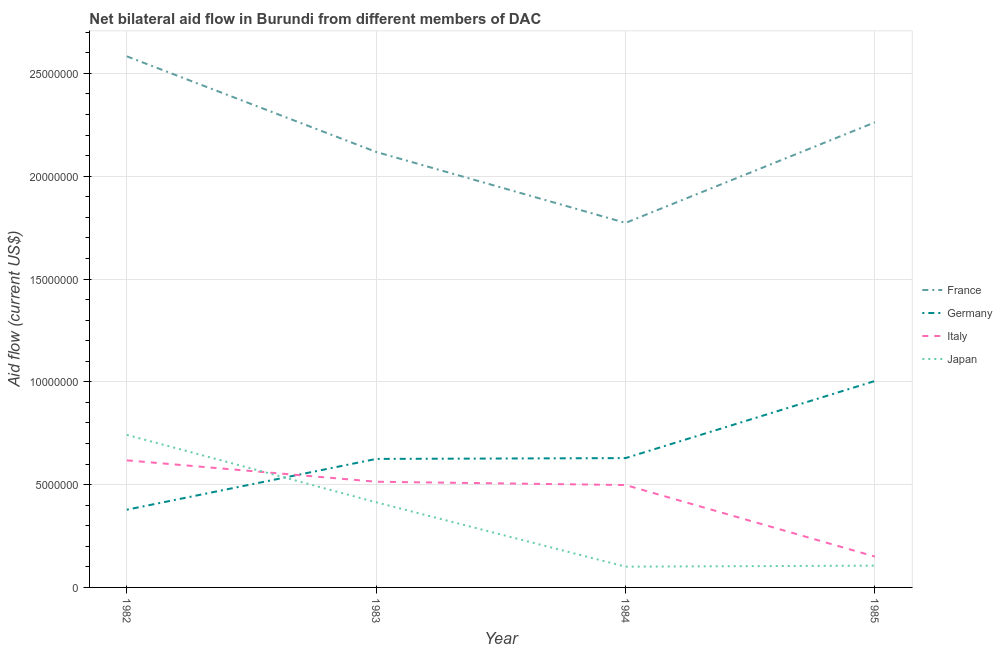How many different coloured lines are there?
Provide a succinct answer. 4. Does the line corresponding to amount of aid given by france intersect with the line corresponding to amount of aid given by germany?
Your answer should be very brief. No. Is the number of lines equal to the number of legend labels?
Make the answer very short. Yes. What is the amount of aid given by italy in 1985?
Ensure brevity in your answer.  1.50e+06. Across all years, what is the maximum amount of aid given by france?
Offer a terse response. 2.58e+07. Across all years, what is the minimum amount of aid given by japan?
Your answer should be very brief. 1.01e+06. In which year was the amount of aid given by italy maximum?
Keep it short and to the point. 1982. In which year was the amount of aid given by italy minimum?
Offer a terse response. 1985. What is the total amount of aid given by france in the graph?
Provide a succinct answer. 8.74e+07. What is the difference between the amount of aid given by france in 1982 and that in 1985?
Offer a very short reply. 3.21e+06. What is the difference between the amount of aid given by germany in 1982 and the amount of aid given by italy in 1983?
Make the answer very short. -1.36e+06. What is the average amount of aid given by italy per year?
Keep it short and to the point. 4.45e+06. In the year 1984, what is the difference between the amount of aid given by germany and amount of aid given by france?
Give a very brief answer. -1.14e+07. In how many years, is the amount of aid given by germany greater than 13000000 US$?
Ensure brevity in your answer.  0. What is the ratio of the amount of aid given by germany in 1983 to that in 1985?
Make the answer very short. 0.62. Is the amount of aid given by italy in 1982 less than that in 1983?
Provide a short and direct response. No. Is the difference between the amount of aid given by france in 1983 and 1984 greater than the difference between the amount of aid given by germany in 1983 and 1984?
Make the answer very short. Yes. What is the difference between the highest and the second highest amount of aid given by japan?
Offer a very short reply. 3.28e+06. What is the difference between the highest and the lowest amount of aid given by france?
Make the answer very short. 8.10e+06. Is it the case that in every year, the sum of the amount of aid given by italy and amount of aid given by japan is greater than the sum of amount of aid given by germany and amount of aid given by france?
Your answer should be compact. No. Is it the case that in every year, the sum of the amount of aid given by france and amount of aid given by germany is greater than the amount of aid given by italy?
Your answer should be compact. Yes. Does the amount of aid given by italy monotonically increase over the years?
Your response must be concise. No. Is the amount of aid given by france strictly greater than the amount of aid given by japan over the years?
Your response must be concise. Yes. Is the amount of aid given by japan strictly less than the amount of aid given by italy over the years?
Provide a succinct answer. No. How many lines are there?
Your answer should be compact. 4. How many years are there in the graph?
Your response must be concise. 4. What is the difference between two consecutive major ticks on the Y-axis?
Ensure brevity in your answer.  5.00e+06. Does the graph contain any zero values?
Offer a very short reply. No. How many legend labels are there?
Offer a terse response. 4. How are the legend labels stacked?
Keep it short and to the point. Vertical. What is the title of the graph?
Keep it short and to the point. Net bilateral aid flow in Burundi from different members of DAC. What is the Aid flow (current US$) in France in 1982?
Offer a terse response. 2.58e+07. What is the Aid flow (current US$) of Germany in 1982?
Your answer should be very brief. 3.78e+06. What is the Aid flow (current US$) in Italy in 1982?
Offer a terse response. 6.18e+06. What is the Aid flow (current US$) of Japan in 1982?
Offer a very short reply. 7.42e+06. What is the Aid flow (current US$) of France in 1983?
Your answer should be very brief. 2.12e+07. What is the Aid flow (current US$) in Germany in 1983?
Keep it short and to the point. 6.25e+06. What is the Aid flow (current US$) in Italy in 1983?
Ensure brevity in your answer.  5.14e+06. What is the Aid flow (current US$) in Japan in 1983?
Offer a terse response. 4.14e+06. What is the Aid flow (current US$) in France in 1984?
Provide a succinct answer. 1.77e+07. What is the Aid flow (current US$) of Germany in 1984?
Your answer should be very brief. 6.29e+06. What is the Aid flow (current US$) of Italy in 1984?
Offer a terse response. 4.98e+06. What is the Aid flow (current US$) of Japan in 1984?
Offer a very short reply. 1.01e+06. What is the Aid flow (current US$) of France in 1985?
Provide a short and direct response. 2.26e+07. What is the Aid flow (current US$) of Germany in 1985?
Make the answer very short. 1.00e+07. What is the Aid flow (current US$) in Italy in 1985?
Provide a succinct answer. 1.50e+06. What is the Aid flow (current US$) of Japan in 1985?
Ensure brevity in your answer.  1.06e+06. Across all years, what is the maximum Aid flow (current US$) in France?
Offer a terse response. 2.58e+07. Across all years, what is the maximum Aid flow (current US$) of Germany?
Ensure brevity in your answer.  1.00e+07. Across all years, what is the maximum Aid flow (current US$) of Italy?
Make the answer very short. 6.18e+06. Across all years, what is the maximum Aid flow (current US$) in Japan?
Offer a very short reply. 7.42e+06. Across all years, what is the minimum Aid flow (current US$) in France?
Your answer should be compact. 1.77e+07. Across all years, what is the minimum Aid flow (current US$) of Germany?
Your response must be concise. 3.78e+06. Across all years, what is the minimum Aid flow (current US$) of Italy?
Keep it short and to the point. 1.50e+06. Across all years, what is the minimum Aid flow (current US$) in Japan?
Provide a short and direct response. 1.01e+06. What is the total Aid flow (current US$) of France in the graph?
Your answer should be very brief. 8.74e+07. What is the total Aid flow (current US$) in Germany in the graph?
Keep it short and to the point. 2.64e+07. What is the total Aid flow (current US$) in Italy in the graph?
Make the answer very short. 1.78e+07. What is the total Aid flow (current US$) in Japan in the graph?
Your answer should be compact. 1.36e+07. What is the difference between the Aid flow (current US$) in France in 1982 and that in 1983?
Your answer should be very brief. 4.65e+06. What is the difference between the Aid flow (current US$) in Germany in 1982 and that in 1983?
Provide a succinct answer. -2.47e+06. What is the difference between the Aid flow (current US$) in Italy in 1982 and that in 1983?
Ensure brevity in your answer.  1.04e+06. What is the difference between the Aid flow (current US$) in Japan in 1982 and that in 1983?
Your answer should be very brief. 3.28e+06. What is the difference between the Aid flow (current US$) in France in 1982 and that in 1984?
Make the answer very short. 8.10e+06. What is the difference between the Aid flow (current US$) of Germany in 1982 and that in 1984?
Your answer should be very brief. -2.51e+06. What is the difference between the Aid flow (current US$) in Italy in 1982 and that in 1984?
Keep it short and to the point. 1.20e+06. What is the difference between the Aid flow (current US$) in Japan in 1982 and that in 1984?
Offer a very short reply. 6.41e+06. What is the difference between the Aid flow (current US$) of France in 1982 and that in 1985?
Provide a succinct answer. 3.21e+06. What is the difference between the Aid flow (current US$) in Germany in 1982 and that in 1985?
Offer a terse response. -6.26e+06. What is the difference between the Aid flow (current US$) in Italy in 1982 and that in 1985?
Your response must be concise. 4.68e+06. What is the difference between the Aid flow (current US$) in Japan in 1982 and that in 1985?
Provide a succinct answer. 6.36e+06. What is the difference between the Aid flow (current US$) in France in 1983 and that in 1984?
Give a very brief answer. 3.45e+06. What is the difference between the Aid flow (current US$) in Italy in 1983 and that in 1984?
Your response must be concise. 1.60e+05. What is the difference between the Aid flow (current US$) in Japan in 1983 and that in 1984?
Your response must be concise. 3.13e+06. What is the difference between the Aid flow (current US$) of France in 1983 and that in 1985?
Offer a very short reply. -1.44e+06. What is the difference between the Aid flow (current US$) in Germany in 1983 and that in 1985?
Keep it short and to the point. -3.79e+06. What is the difference between the Aid flow (current US$) in Italy in 1983 and that in 1985?
Offer a terse response. 3.64e+06. What is the difference between the Aid flow (current US$) of Japan in 1983 and that in 1985?
Ensure brevity in your answer.  3.08e+06. What is the difference between the Aid flow (current US$) in France in 1984 and that in 1985?
Offer a terse response. -4.89e+06. What is the difference between the Aid flow (current US$) of Germany in 1984 and that in 1985?
Offer a terse response. -3.75e+06. What is the difference between the Aid flow (current US$) in Italy in 1984 and that in 1985?
Provide a succinct answer. 3.48e+06. What is the difference between the Aid flow (current US$) of Japan in 1984 and that in 1985?
Provide a succinct answer. -5.00e+04. What is the difference between the Aid flow (current US$) in France in 1982 and the Aid flow (current US$) in Germany in 1983?
Make the answer very short. 1.96e+07. What is the difference between the Aid flow (current US$) of France in 1982 and the Aid flow (current US$) of Italy in 1983?
Make the answer very short. 2.07e+07. What is the difference between the Aid flow (current US$) of France in 1982 and the Aid flow (current US$) of Japan in 1983?
Make the answer very short. 2.17e+07. What is the difference between the Aid flow (current US$) in Germany in 1982 and the Aid flow (current US$) in Italy in 1983?
Offer a terse response. -1.36e+06. What is the difference between the Aid flow (current US$) of Germany in 1982 and the Aid flow (current US$) of Japan in 1983?
Provide a short and direct response. -3.60e+05. What is the difference between the Aid flow (current US$) in Italy in 1982 and the Aid flow (current US$) in Japan in 1983?
Your answer should be very brief. 2.04e+06. What is the difference between the Aid flow (current US$) in France in 1982 and the Aid flow (current US$) in Germany in 1984?
Your response must be concise. 1.95e+07. What is the difference between the Aid flow (current US$) in France in 1982 and the Aid flow (current US$) in Italy in 1984?
Your answer should be compact. 2.08e+07. What is the difference between the Aid flow (current US$) of France in 1982 and the Aid flow (current US$) of Japan in 1984?
Provide a short and direct response. 2.48e+07. What is the difference between the Aid flow (current US$) in Germany in 1982 and the Aid flow (current US$) in Italy in 1984?
Offer a terse response. -1.20e+06. What is the difference between the Aid flow (current US$) in Germany in 1982 and the Aid flow (current US$) in Japan in 1984?
Ensure brevity in your answer.  2.77e+06. What is the difference between the Aid flow (current US$) in Italy in 1982 and the Aid flow (current US$) in Japan in 1984?
Keep it short and to the point. 5.17e+06. What is the difference between the Aid flow (current US$) of France in 1982 and the Aid flow (current US$) of Germany in 1985?
Provide a succinct answer. 1.58e+07. What is the difference between the Aid flow (current US$) in France in 1982 and the Aid flow (current US$) in Italy in 1985?
Give a very brief answer. 2.43e+07. What is the difference between the Aid flow (current US$) in France in 1982 and the Aid flow (current US$) in Japan in 1985?
Give a very brief answer. 2.48e+07. What is the difference between the Aid flow (current US$) in Germany in 1982 and the Aid flow (current US$) in Italy in 1985?
Your answer should be compact. 2.28e+06. What is the difference between the Aid flow (current US$) in Germany in 1982 and the Aid flow (current US$) in Japan in 1985?
Offer a very short reply. 2.72e+06. What is the difference between the Aid flow (current US$) of Italy in 1982 and the Aid flow (current US$) of Japan in 1985?
Make the answer very short. 5.12e+06. What is the difference between the Aid flow (current US$) of France in 1983 and the Aid flow (current US$) of Germany in 1984?
Offer a very short reply. 1.49e+07. What is the difference between the Aid flow (current US$) of France in 1983 and the Aid flow (current US$) of Italy in 1984?
Provide a short and direct response. 1.62e+07. What is the difference between the Aid flow (current US$) in France in 1983 and the Aid flow (current US$) in Japan in 1984?
Ensure brevity in your answer.  2.02e+07. What is the difference between the Aid flow (current US$) in Germany in 1983 and the Aid flow (current US$) in Italy in 1984?
Your answer should be very brief. 1.27e+06. What is the difference between the Aid flow (current US$) in Germany in 1983 and the Aid flow (current US$) in Japan in 1984?
Provide a succinct answer. 5.24e+06. What is the difference between the Aid flow (current US$) in Italy in 1983 and the Aid flow (current US$) in Japan in 1984?
Provide a succinct answer. 4.13e+06. What is the difference between the Aid flow (current US$) in France in 1983 and the Aid flow (current US$) in Germany in 1985?
Provide a short and direct response. 1.11e+07. What is the difference between the Aid flow (current US$) of France in 1983 and the Aid flow (current US$) of Italy in 1985?
Your answer should be compact. 1.97e+07. What is the difference between the Aid flow (current US$) in France in 1983 and the Aid flow (current US$) in Japan in 1985?
Give a very brief answer. 2.01e+07. What is the difference between the Aid flow (current US$) in Germany in 1983 and the Aid flow (current US$) in Italy in 1985?
Your answer should be compact. 4.75e+06. What is the difference between the Aid flow (current US$) of Germany in 1983 and the Aid flow (current US$) of Japan in 1985?
Give a very brief answer. 5.19e+06. What is the difference between the Aid flow (current US$) of Italy in 1983 and the Aid flow (current US$) of Japan in 1985?
Keep it short and to the point. 4.08e+06. What is the difference between the Aid flow (current US$) in France in 1984 and the Aid flow (current US$) in Germany in 1985?
Provide a succinct answer. 7.69e+06. What is the difference between the Aid flow (current US$) of France in 1984 and the Aid flow (current US$) of Italy in 1985?
Offer a terse response. 1.62e+07. What is the difference between the Aid flow (current US$) of France in 1984 and the Aid flow (current US$) of Japan in 1985?
Offer a very short reply. 1.67e+07. What is the difference between the Aid flow (current US$) in Germany in 1984 and the Aid flow (current US$) in Italy in 1985?
Provide a succinct answer. 4.79e+06. What is the difference between the Aid flow (current US$) of Germany in 1984 and the Aid flow (current US$) of Japan in 1985?
Make the answer very short. 5.23e+06. What is the difference between the Aid flow (current US$) in Italy in 1984 and the Aid flow (current US$) in Japan in 1985?
Ensure brevity in your answer.  3.92e+06. What is the average Aid flow (current US$) in France per year?
Make the answer very short. 2.18e+07. What is the average Aid flow (current US$) of Germany per year?
Make the answer very short. 6.59e+06. What is the average Aid flow (current US$) of Italy per year?
Offer a very short reply. 4.45e+06. What is the average Aid flow (current US$) of Japan per year?
Ensure brevity in your answer.  3.41e+06. In the year 1982, what is the difference between the Aid flow (current US$) of France and Aid flow (current US$) of Germany?
Provide a short and direct response. 2.20e+07. In the year 1982, what is the difference between the Aid flow (current US$) of France and Aid flow (current US$) of Italy?
Your response must be concise. 1.96e+07. In the year 1982, what is the difference between the Aid flow (current US$) of France and Aid flow (current US$) of Japan?
Provide a short and direct response. 1.84e+07. In the year 1982, what is the difference between the Aid flow (current US$) in Germany and Aid flow (current US$) in Italy?
Your answer should be compact. -2.40e+06. In the year 1982, what is the difference between the Aid flow (current US$) of Germany and Aid flow (current US$) of Japan?
Your response must be concise. -3.64e+06. In the year 1982, what is the difference between the Aid flow (current US$) of Italy and Aid flow (current US$) of Japan?
Give a very brief answer. -1.24e+06. In the year 1983, what is the difference between the Aid flow (current US$) of France and Aid flow (current US$) of Germany?
Ensure brevity in your answer.  1.49e+07. In the year 1983, what is the difference between the Aid flow (current US$) of France and Aid flow (current US$) of Italy?
Your response must be concise. 1.60e+07. In the year 1983, what is the difference between the Aid flow (current US$) in France and Aid flow (current US$) in Japan?
Your answer should be compact. 1.70e+07. In the year 1983, what is the difference between the Aid flow (current US$) of Germany and Aid flow (current US$) of Italy?
Your response must be concise. 1.11e+06. In the year 1983, what is the difference between the Aid flow (current US$) of Germany and Aid flow (current US$) of Japan?
Offer a very short reply. 2.11e+06. In the year 1983, what is the difference between the Aid flow (current US$) in Italy and Aid flow (current US$) in Japan?
Your response must be concise. 1.00e+06. In the year 1984, what is the difference between the Aid flow (current US$) of France and Aid flow (current US$) of Germany?
Offer a very short reply. 1.14e+07. In the year 1984, what is the difference between the Aid flow (current US$) of France and Aid flow (current US$) of Italy?
Keep it short and to the point. 1.28e+07. In the year 1984, what is the difference between the Aid flow (current US$) in France and Aid flow (current US$) in Japan?
Give a very brief answer. 1.67e+07. In the year 1984, what is the difference between the Aid flow (current US$) in Germany and Aid flow (current US$) in Italy?
Offer a terse response. 1.31e+06. In the year 1984, what is the difference between the Aid flow (current US$) in Germany and Aid flow (current US$) in Japan?
Offer a very short reply. 5.28e+06. In the year 1984, what is the difference between the Aid flow (current US$) in Italy and Aid flow (current US$) in Japan?
Keep it short and to the point. 3.97e+06. In the year 1985, what is the difference between the Aid flow (current US$) in France and Aid flow (current US$) in Germany?
Offer a very short reply. 1.26e+07. In the year 1985, what is the difference between the Aid flow (current US$) in France and Aid flow (current US$) in Italy?
Offer a terse response. 2.11e+07. In the year 1985, what is the difference between the Aid flow (current US$) of France and Aid flow (current US$) of Japan?
Your response must be concise. 2.16e+07. In the year 1985, what is the difference between the Aid flow (current US$) in Germany and Aid flow (current US$) in Italy?
Offer a terse response. 8.54e+06. In the year 1985, what is the difference between the Aid flow (current US$) of Germany and Aid flow (current US$) of Japan?
Provide a short and direct response. 8.98e+06. In the year 1985, what is the difference between the Aid flow (current US$) in Italy and Aid flow (current US$) in Japan?
Your response must be concise. 4.40e+05. What is the ratio of the Aid flow (current US$) of France in 1982 to that in 1983?
Provide a short and direct response. 1.22. What is the ratio of the Aid flow (current US$) in Germany in 1982 to that in 1983?
Make the answer very short. 0.6. What is the ratio of the Aid flow (current US$) in Italy in 1982 to that in 1983?
Your answer should be compact. 1.2. What is the ratio of the Aid flow (current US$) of Japan in 1982 to that in 1983?
Your answer should be compact. 1.79. What is the ratio of the Aid flow (current US$) in France in 1982 to that in 1984?
Provide a short and direct response. 1.46. What is the ratio of the Aid flow (current US$) of Germany in 1982 to that in 1984?
Your response must be concise. 0.6. What is the ratio of the Aid flow (current US$) of Italy in 1982 to that in 1984?
Ensure brevity in your answer.  1.24. What is the ratio of the Aid flow (current US$) in Japan in 1982 to that in 1984?
Keep it short and to the point. 7.35. What is the ratio of the Aid flow (current US$) in France in 1982 to that in 1985?
Your answer should be compact. 1.14. What is the ratio of the Aid flow (current US$) of Germany in 1982 to that in 1985?
Keep it short and to the point. 0.38. What is the ratio of the Aid flow (current US$) in Italy in 1982 to that in 1985?
Offer a very short reply. 4.12. What is the ratio of the Aid flow (current US$) in France in 1983 to that in 1984?
Your answer should be very brief. 1.19. What is the ratio of the Aid flow (current US$) in Italy in 1983 to that in 1984?
Provide a short and direct response. 1.03. What is the ratio of the Aid flow (current US$) in Japan in 1983 to that in 1984?
Your answer should be compact. 4.1. What is the ratio of the Aid flow (current US$) in France in 1983 to that in 1985?
Provide a short and direct response. 0.94. What is the ratio of the Aid flow (current US$) in Germany in 1983 to that in 1985?
Give a very brief answer. 0.62. What is the ratio of the Aid flow (current US$) of Italy in 1983 to that in 1985?
Provide a short and direct response. 3.43. What is the ratio of the Aid flow (current US$) of Japan in 1983 to that in 1985?
Your answer should be very brief. 3.91. What is the ratio of the Aid flow (current US$) in France in 1984 to that in 1985?
Make the answer very short. 0.78. What is the ratio of the Aid flow (current US$) of Germany in 1984 to that in 1985?
Your response must be concise. 0.63. What is the ratio of the Aid flow (current US$) in Italy in 1984 to that in 1985?
Keep it short and to the point. 3.32. What is the ratio of the Aid flow (current US$) in Japan in 1984 to that in 1985?
Offer a very short reply. 0.95. What is the difference between the highest and the second highest Aid flow (current US$) of France?
Offer a very short reply. 3.21e+06. What is the difference between the highest and the second highest Aid flow (current US$) of Germany?
Keep it short and to the point. 3.75e+06. What is the difference between the highest and the second highest Aid flow (current US$) in Italy?
Give a very brief answer. 1.04e+06. What is the difference between the highest and the second highest Aid flow (current US$) in Japan?
Provide a short and direct response. 3.28e+06. What is the difference between the highest and the lowest Aid flow (current US$) in France?
Your answer should be compact. 8.10e+06. What is the difference between the highest and the lowest Aid flow (current US$) in Germany?
Provide a short and direct response. 6.26e+06. What is the difference between the highest and the lowest Aid flow (current US$) of Italy?
Your response must be concise. 4.68e+06. What is the difference between the highest and the lowest Aid flow (current US$) in Japan?
Keep it short and to the point. 6.41e+06. 